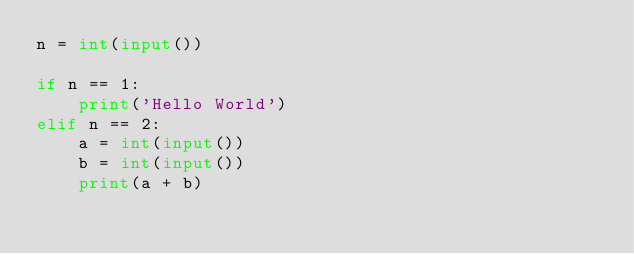Convert code to text. <code><loc_0><loc_0><loc_500><loc_500><_Python_>n = int(input())

if n == 1:
    print('Hello World')
elif n == 2:
    a = int(input())
    b = int(input())
    print(a + b)</code> 